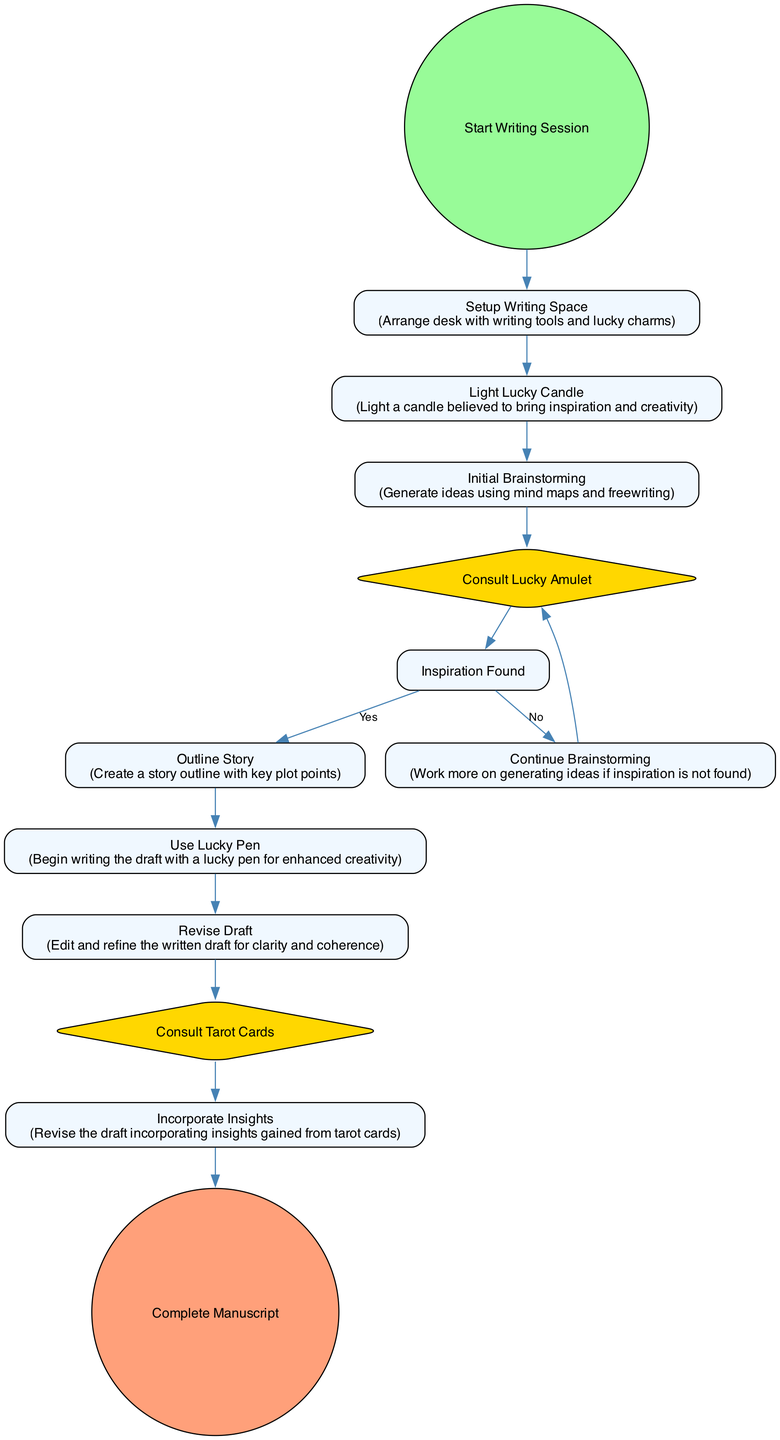What is the first activity in the diagram? The first activity in the diagram is directly connected to the Start Writing Session node and is labeled Setup Writing Space.
Answer: Setup Writing Space How many decision nodes are present in the diagram? The diagram contains two decision nodes: Consult Lucky Amulet and Consult Tarot Cards.
Answer: 2 What is the activity that follows outlining the story? After the Outline Story activity, the next activity is Use Lucky Pen.
Answer: Use Lucky Pen What happens if inspiration is not found after consulting the lucky amulet? If inspiration is not found, the flow continues to the Continue Brainstorming activity, which indicates further idea generation is needed.
Answer: Continue Brainstorming How many edges lead from the Initial Brainstorming node? There are two edges leading out from the Initial Brainstorming node: one to Consult Lucky Amulet and the other one indicating that it leads to the decision about Inspiration Found.
Answer: 2 What is the last activity before completing the manuscript? The last activity before the Complete Manuscript node is Incorporate Insights, as it follows the Consult Tarot Cards node.
Answer: Incorporate Insights Which activity utilizes a lucky pen to write the draft? The activity where the lucky pen is used to begin writing the draft is labeled Use Lucky Pen.
Answer: Use Lucky Pen What is the outcome of lighting the lucky candle according to the diagram? Lighting the lucky candle directly leads to Initial Brainstorming, suggesting it helps initiate the idea generation phase.
Answer: Initial Brainstorming What activity is performed after revising the draft? After the Revise Draft activity, the next step is to Consult Tarot Cards for unique insights.
Answer: Consult Tarot Cards 